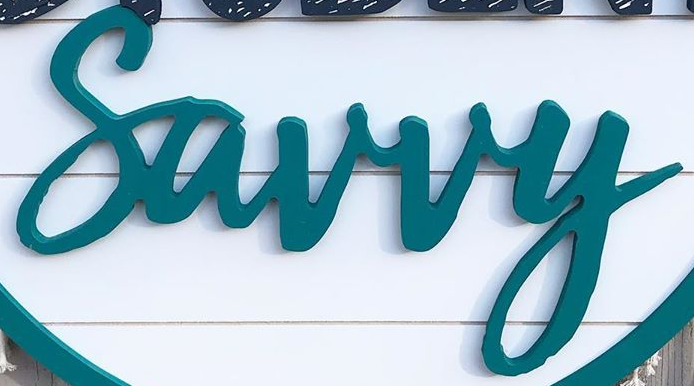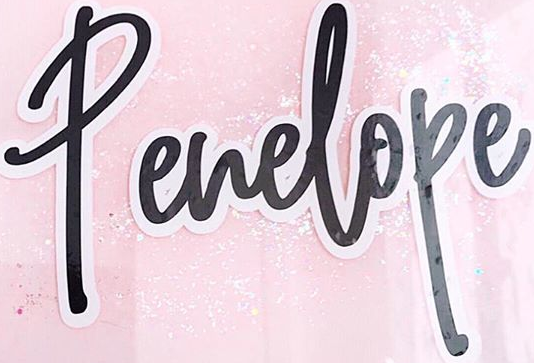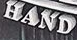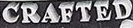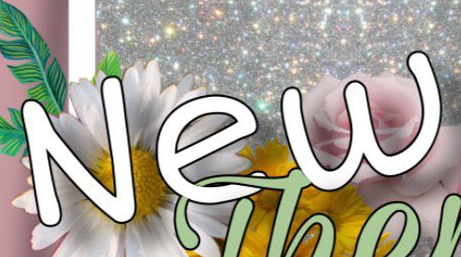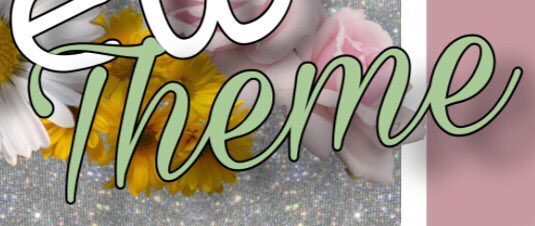What text is displayed in these images sequentially, separated by a semicolon? Surry; Penelope; HAND; CRAFTED; New; Theme 